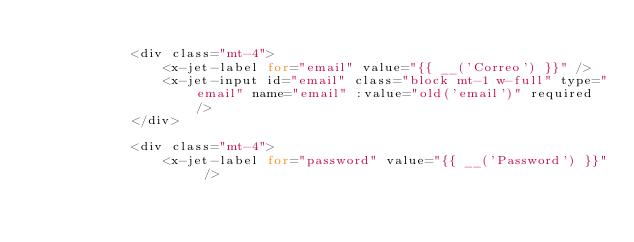<code> <loc_0><loc_0><loc_500><loc_500><_PHP_>
            <div class="mt-4">
                <x-jet-label for="email" value="{{ __('Correo') }}" />
                <x-jet-input id="email" class="block mt-1 w-full" type="email" name="email" :value="old('email')" required />
            </div>

            <div class="mt-4">
                <x-jet-label for="password" value="{{ __('Password') }}" /></code> 